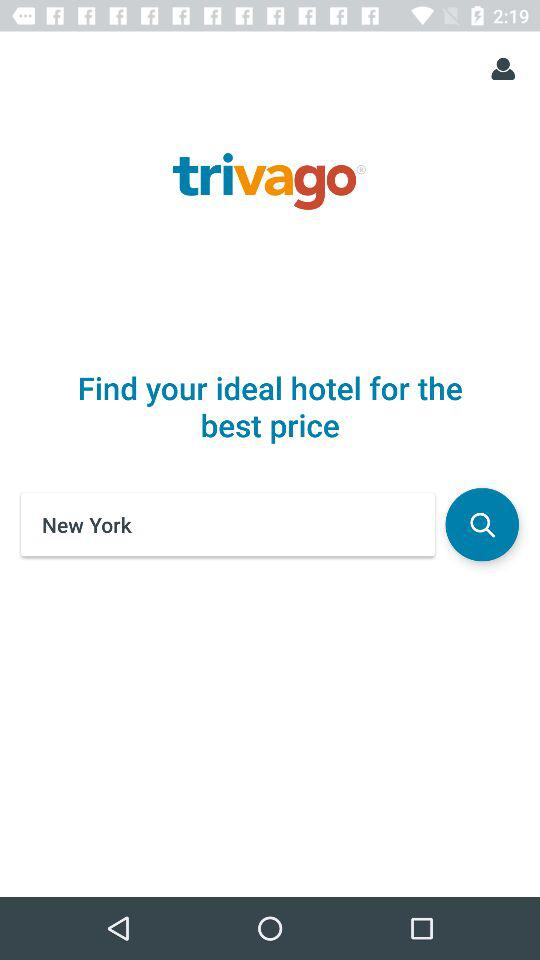What is the name of the application? The name of the application is "trivago". 